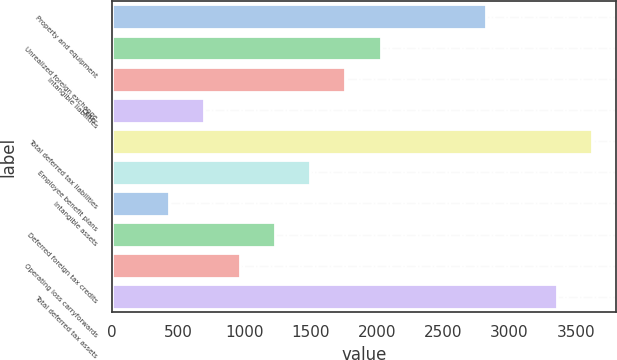Convert chart to OTSL. <chart><loc_0><loc_0><loc_500><loc_500><bar_chart><fcel>Property and equipment<fcel>Unrealized foreign exchange<fcel>Intangible liabilities<fcel>Other<fcel>Total deferred tax liabilities<fcel>Employee benefit plans<fcel>Intangible assets<fcel>Deferred foreign tax credits<fcel>Operating loss carryforwards<fcel>Total deferred tax assets<nl><fcel>2823.5<fcel>2026.85<fcel>1761.3<fcel>699.1<fcel>3620.15<fcel>1495.75<fcel>433.55<fcel>1230.2<fcel>964.65<fcel>3354.6<nl></chart> 